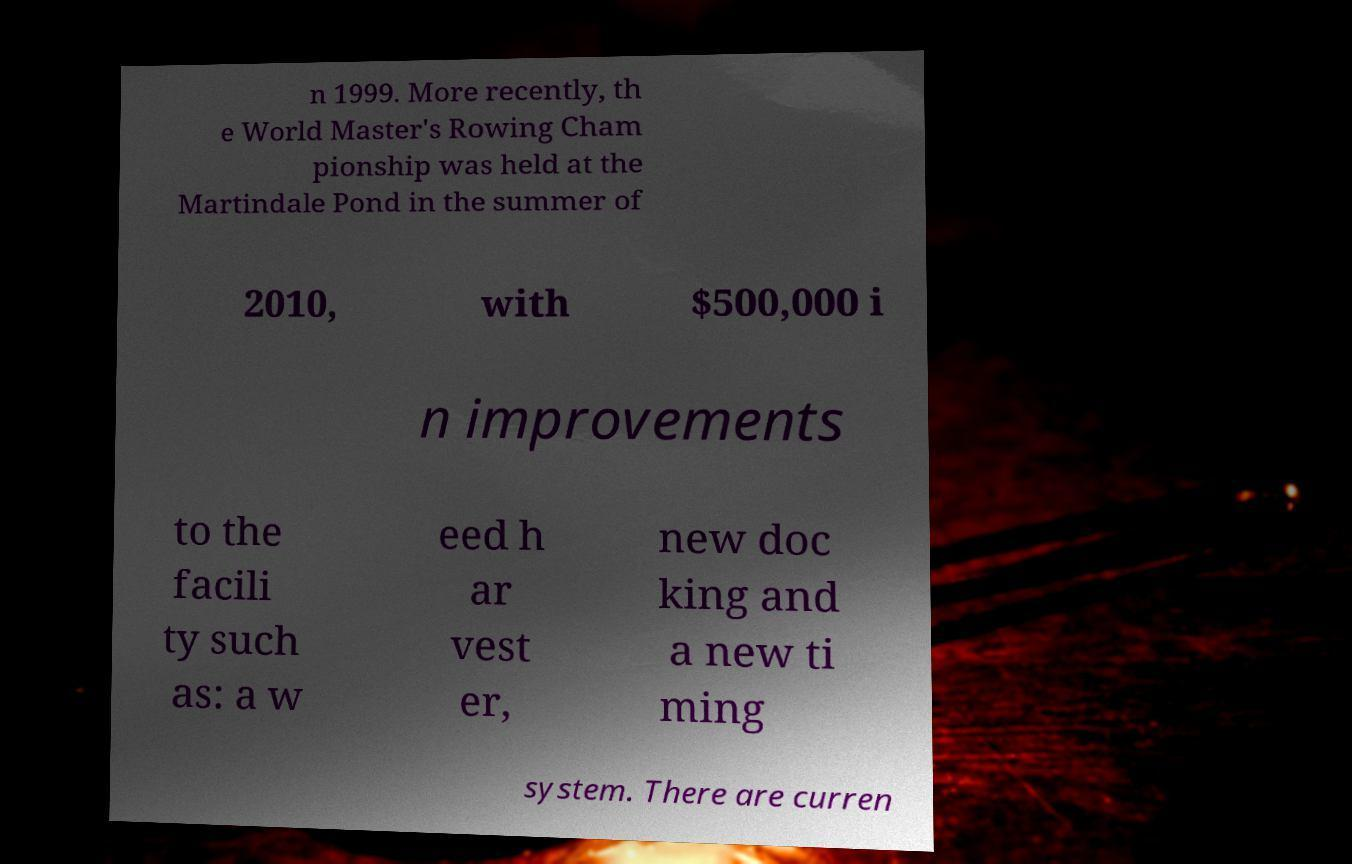I need the written content from this picture converted into text. Can you do that? n 1999. More recently, th e World Master's Rowing Cham pionship was held at the Martindale Pond in the summer of 2010, with $500,000 i n improvements to the facili ty such as: a w eed h ar vest er, new doc king and a new ti ming system. There are curren 